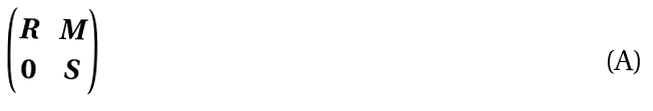<formula> <loc_0><loc_0><loc_500><loc_500>\begin{pmatrix} R & M \\ 0 & S \\ \end{pmatrix}</formula> 